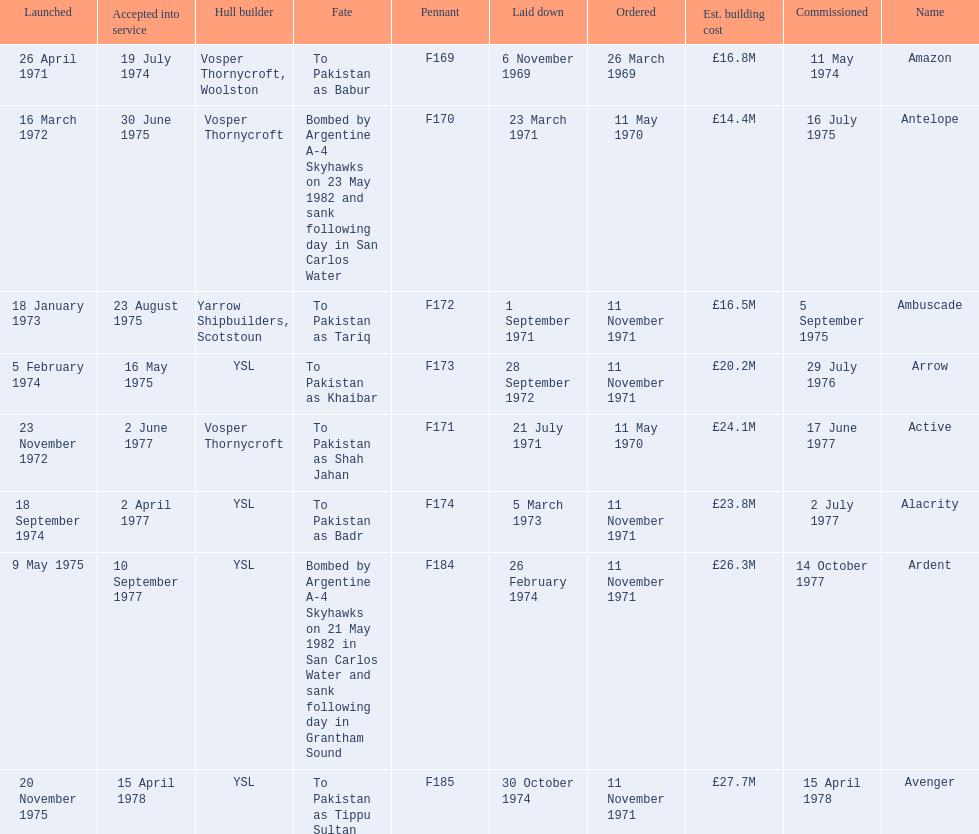Which type 21 frigate ships were to be built by ysl in the 1970s? Arrow, Alacrity, Ardent, Avenger. Of these ships, which one had the highest estimated building cost? Avenger. 